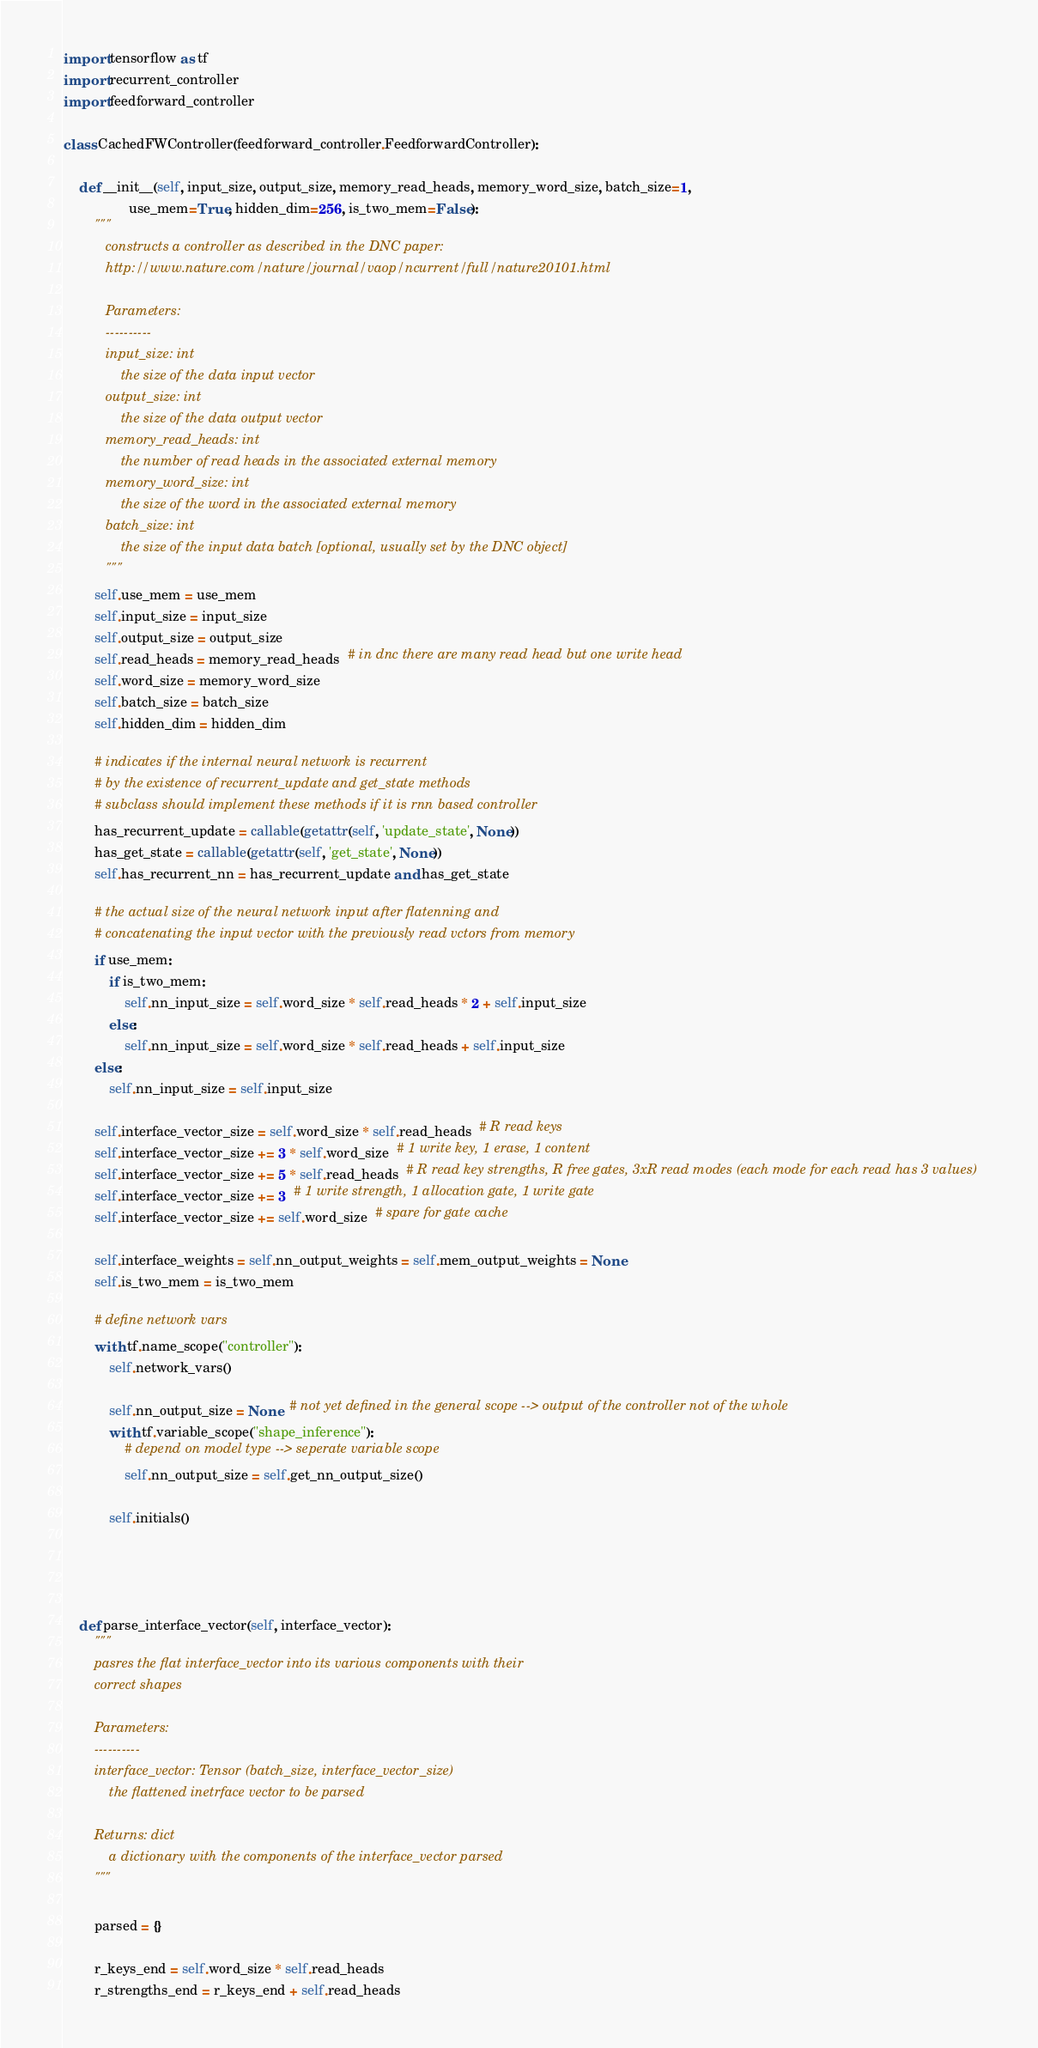Convert code to text. <code><loc_0><loc_0><loc_500><loc_500><_Python_>import tensorflow as tf
import recurrent_controller
import feedforward_controller

class CachedFWController(feedforward_controller.FeedforwardController):

    def __init__(self, input_size, output_size, memory_read_heads, memory_word_size, batch_size=1,
                 use_mem=True, hidden_dim=256, is_two_mem=False):
        """
           constructs a controller as described in the DNC paper:
           http://www.nature.com/nature/journal/vaop/ncurrent/full/nature20101.html

           Parameters:
           ----------
           input_size: int
               the size of the data input vector
           output_size: int
               the size of the data output vector
           memory_read_heads: int
               the number of read heads in the associated external memory
           memory_word_size: int
               the size of the word in the associated external memory
           batch_size: int
               the size of the input data batch [optional, usually set by the DNC object]
           """
        self.use_mem = use_mem
        self.input_size = input_size
        self.output_size = output_size
        self.read_heads = memory_read_heads  # in dnc there are many read head but one write head
        self.word_size = memory_word_size
        self.batch_size = batch_size
        self.hidden_dim = hidden_dim

        # indicates if the internal neural network is recurrent
        # by the existence of recurrent_update and get_state methods
        # subclass should implement these methods if it is rnn based controller
        has_recurrent_update = callable(getattr(self, 'update_state', None))
        has_get_state = callable(getattr(self, 'get_state', None))
        self.has_recurrent_nn = has_recurrent_update and has_get_state

        # the actual size of the neural network input after flatenning and
        # concatenating the input vector with the previously read vctors from memory
        if use_mem:
            if is_two_mem:
                self.nn_input_size = self.word_size * self.read_heads * 2 + self.input_size
            else:
                self.nn_input_size = self.word_size * self.read_heads + self.input_size
        else:
            self.nn_input_size = self.input_size

        self.interface_vector_size = self.word_size * self.read_heads  # R read keys
        self.interface_vector_size += 3 * self.word_size  # 1 write key, 1 erase, 1 content
        self.interface_vector_size += 5 * self.read_heads  # R read key strengths, R free gates, 3xR read modes (each mode for each read has 3 values)
        self.interface_vector_size += 3  # 1 write strength, 1 allocation gate, 1 write gate
        self.interface_vector_size += self.word_size  # spare for gate cache

        self.interface_weights = self.nn_output_weights = self.mem_output_weights = None
        self.is_two_mem = is_two_mem

        # define network vars
        with tf.name_scope("controller"):
            self.network_vars()

            self.nn_output_size = None  # not yet defined in the general scope --> output of the controller not of the whole
            with tf.variable_scope("shape_inference"):
                # depend on model type --> seperate variable scope
                self.nn_output_size = self.get_nn_output_size()

            self.initials()




    def parse_interface_vector(self, interface_vector):
        """
        pasres the flat interface_vector into its various components with their
        correct shapes

        Parameters:
        ----------
        interface_vector: Tensor (batch_size, interface_vector_size)
            the flattened inetrface vector to be parsed

        Returns: dict
            a dictionary with the components of the interface_vector parsed
        """

        parsed = {}

        r_keys_end = self.word_size * self.read_heads
        r_strengths_end = r_keys_end + self.read_heads</code> 